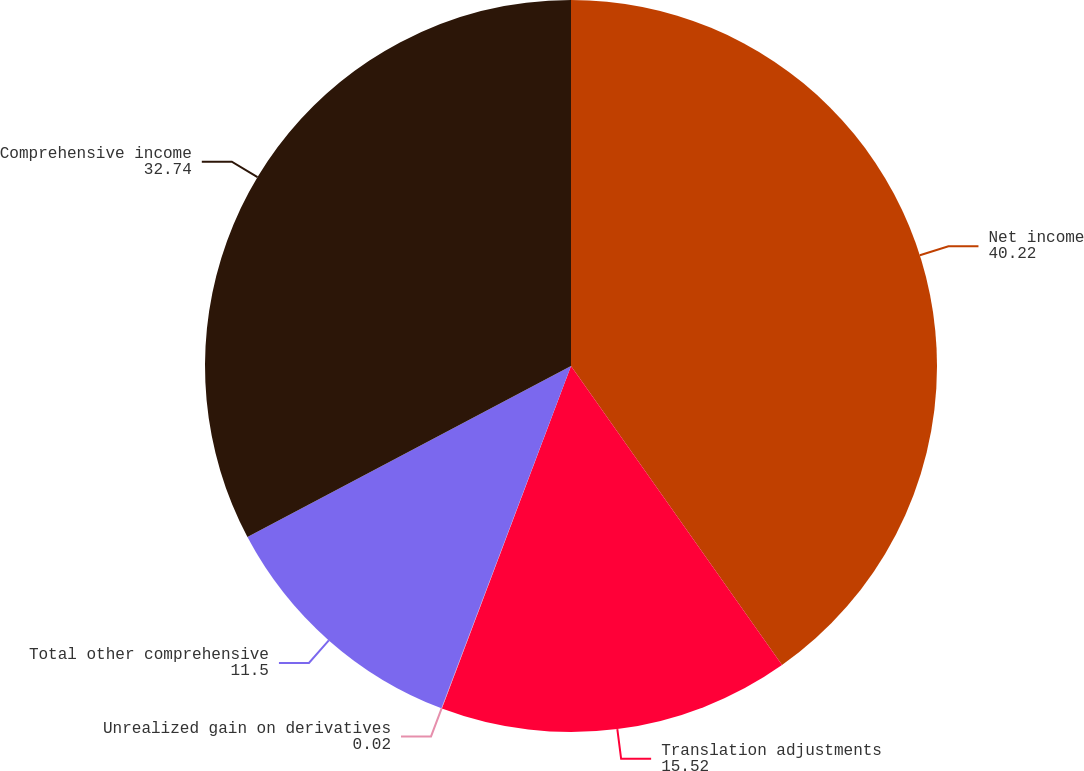Convert chart to OTSL. <chart><loc_0><loc_0><loc_500><loc_500><pie_chart><fcel>Net income<fcel>Translation adjustments<fcel>Unrealized gain on derivatives<fcel>Total other comprehensive<fcel>Comprehensive income<nl><fcel>40.22%<fcel>15.52%<fcel>0.02%<fcel>11.5%<fcel>32.74%<nl></chart> 